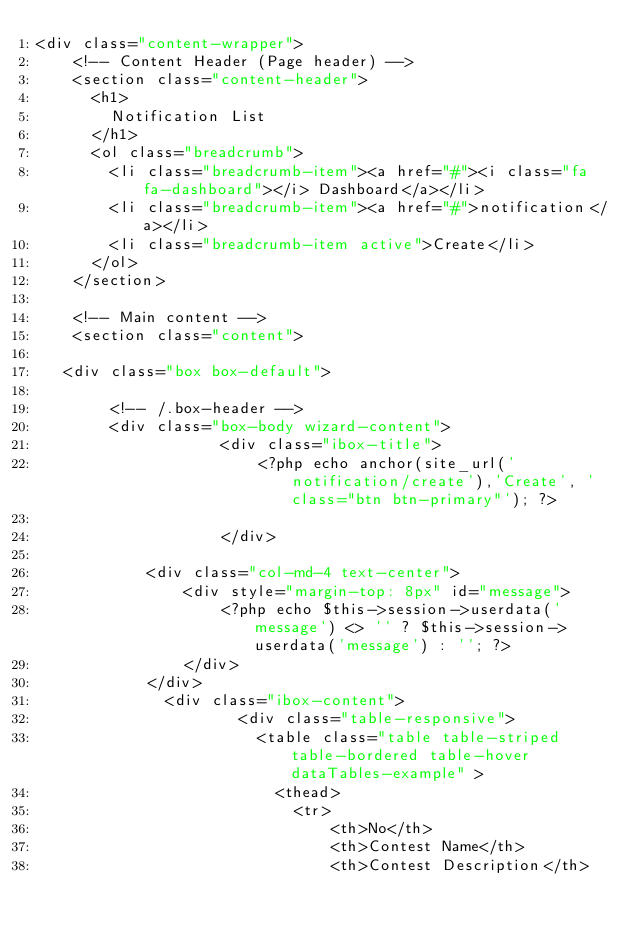Convert code to text. <code><loc_0><loc_0><loc_500><loc_500><_PHP_><div class="content-wrapper">
    <!-- Content Header (Page header) -->
    <section class="content-header">
      <h1>
        Notification List
      </h1>
      <ol class="breadcrumb">
        <li class="breadcrumb-item"><a href="#"><i class="fa fa-dashboard"></i> Dashboard</a></li>
        <li class="breadcrumb-item"><a href="#">notification</a></li>
        <li class="breadcrumb-item active">Create</li>
      </ol>
    </section>

    <!-- Main content -->
    <section class="content">
          
   <div class="box box-default">
        
        <!-- /.box-header -->
        <div class="box-body wizard-content">
                    <div class="ibox-title">
                        <?php echo anchor(site_url('notification/create'),'Create', 'class="btn btn-primary"'); ?>
                     
                    </div>
                    
            <div class="col-md-4 text-center">
                <div style="margin-top: 8px" id="message">
                    <?php echo $this->session->userdata('message') <> '' ? $this->session->userdata('message') : ''; ?>
                </div>
            </div>
              <div class="ibox-content">
                      <div class="table-responsive">
                        <table class="table table-striped table-bordered table-hover dataTables-example" >
                          <thead>
                            <tr>
                                <th>No</th>
                                <th>Contest Name</th>
                                <th>Contest Description</th></code> 